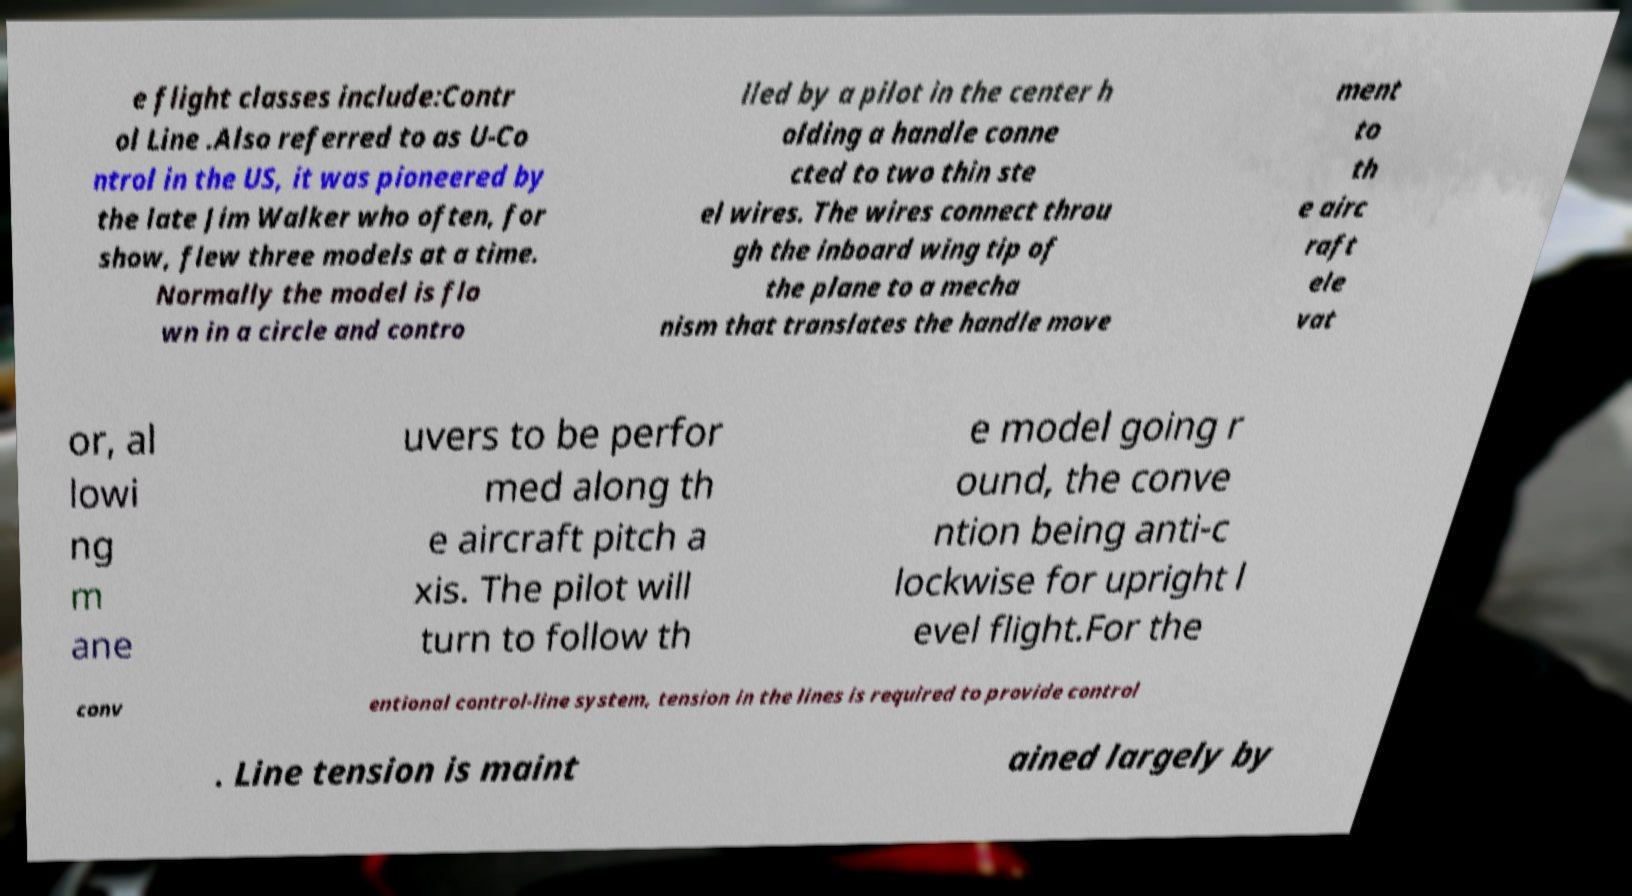Please identify and transcribe the text found in this image. e flight classes include:Contr ol Line .Also referred to as U-Co ntrol in the US, it was pioneered by the late Jim Walker who often, for show, flew three models at a time. Normally the model is flo wn in a circle and contro lled by a pilot in the center h olding a handle conne cted to two thin ste el wires. The wires connect throu gh the inboard wing tip of the plane to a mecha nism that translates the handle move ment to th e airc raft ele vat or, al lowi ng m ane uvers to be perfor med along th e aircraft pitch a xis. The pilot will turn to follow th e model going r ound, the conve ntion being anti-c lockwise for upright l evel flight.For the conv entional control-line system, tension in the lines is required to provide control . Line tension is maint ained largely by 